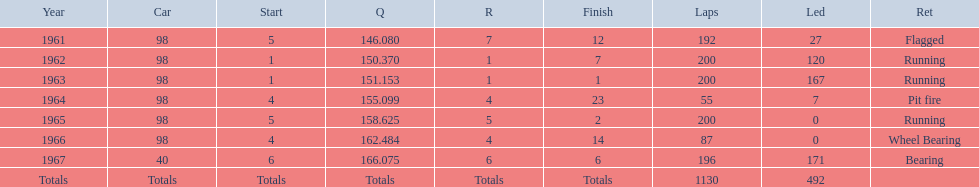What is the difference between the qualfying time in 1967 and 1965? 7.45. 